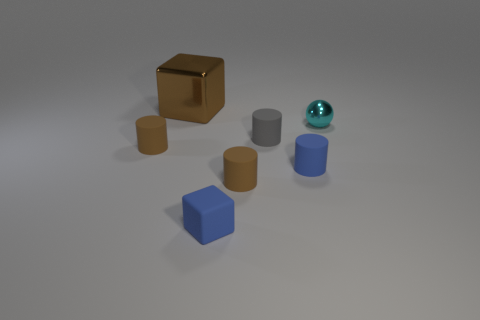There is a small cylinder that is the same color as the small block; what material is it?
Offer a terse response. Rubber. What number of small matte things have the same color as the matte block?
Your answer should be very brief. 1. How many other cyan balls have the same material as the cyan sphere?
Your answer should be compact. 0. There is a small cylinder behind the small brown object that is on the left side of the blue thing on the left side of the small gray object; what color is it?
Keep it short and to the point. Gray. Does the cyan shiny ball have the same size as the rubber cube?
Provide a succinct answer. Yes. Is there any other thing that is the same shape as the cyan object?
Keep it short and to the point. No. What number of objects are either big things on the left side of the blue matte cube or large brown cylinders?
Make the answer very short. 1. How many other objects are the same size as the brown cube?
Keep it short and to the point. 0. The sphere is what color?
Ensure brevity in your answer.  Cyan. How many tiny objects are either yellow shiny spheres or brown rubber cylinders?
Make the answer very short. 2. 